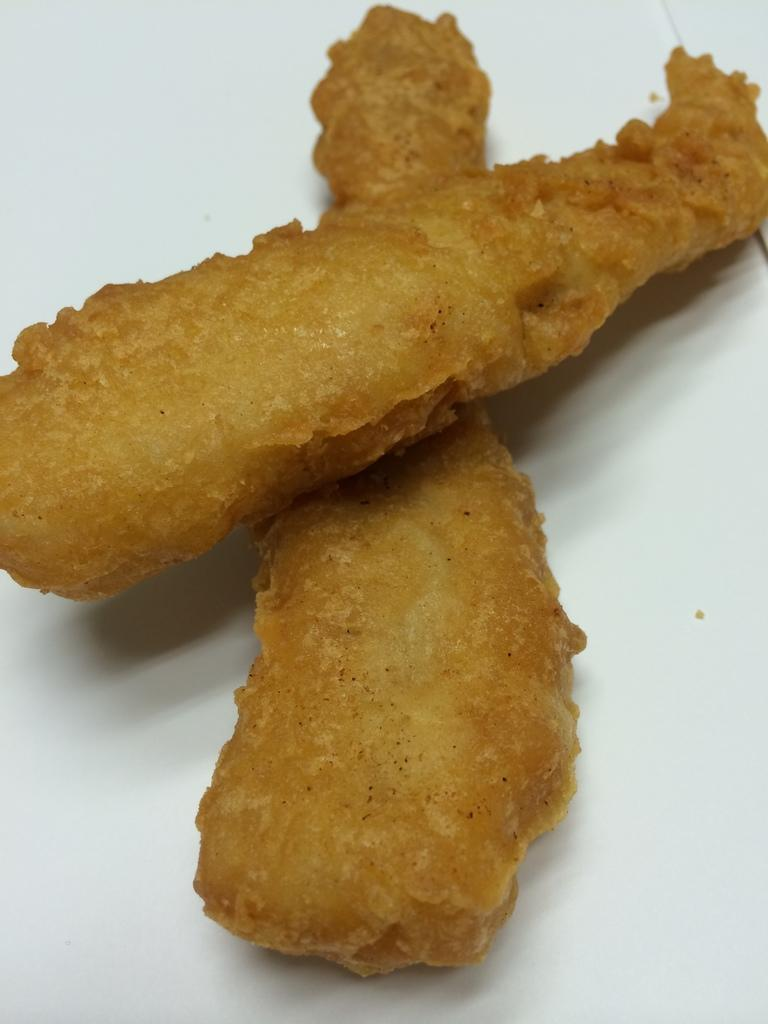What type of food can be seen in the image? There are snacks in the image. What is the color of the surface on which the snacks are placed? The snacks are on a white surface. What type of behavior can be observed in the snacks in the image? The snacks do not exhibit any behavior, as they are inanimate objects. 